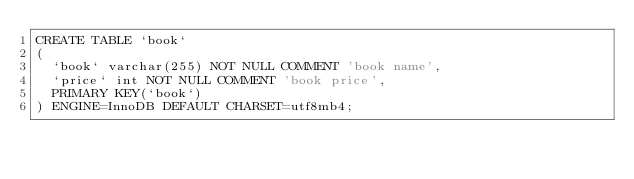<code> <loc_0><loc_0><loc_500><loc_500><_SQL_>CREATE TABLE `book`
(
  `book` varchar(255) NOT NULL COMMENT 'book name',
  `price` int NOT NULL COMMENT 'book price',
  PRIMARY KEY(`book`)
) ENGINE=InnoDB DEFAULT CHARSET=utf8mb4;</code> 